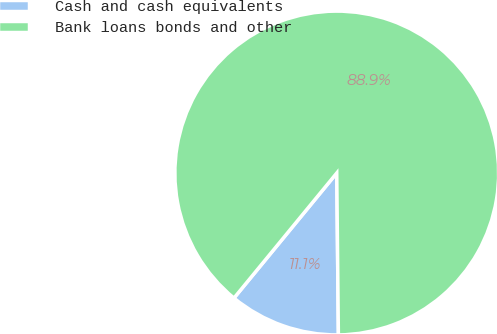<chart> <loc_0><loc_0><loc_500><loc_500><pie_chart><fcel>Cash and cash equivalents<fcel>Bank loans bonds and other<nl><fcel>11.11%<fcel>88.89%<nl></chart> 